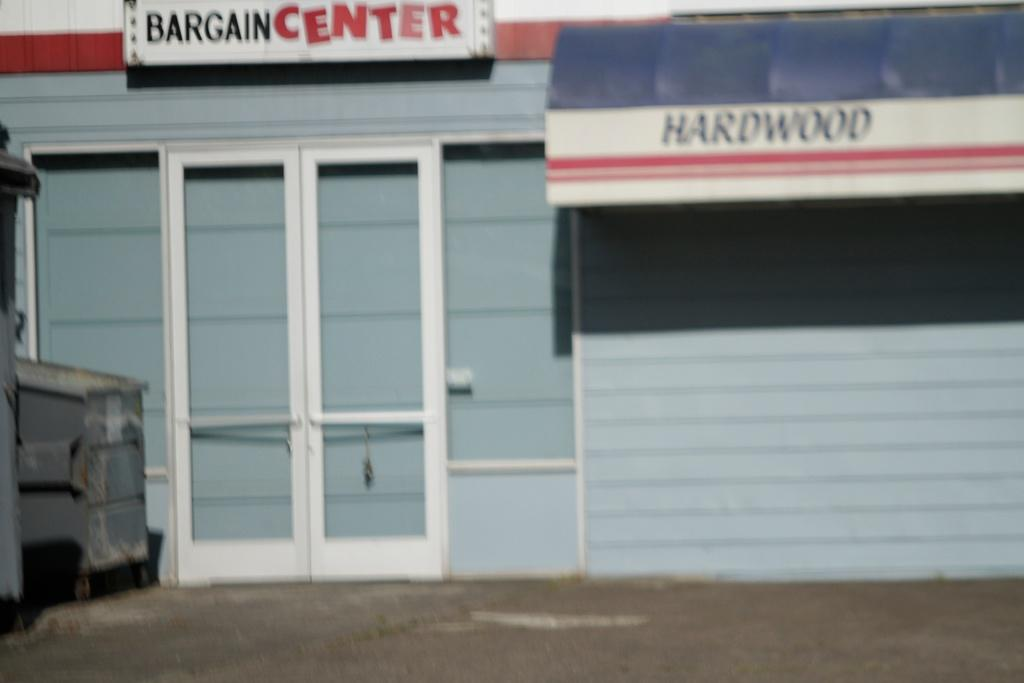What type of structure is visible in the image? There is a building in the image. What is the board used for in the image? The board's purpose is not clear from the image, but it is present. What is attached to the building in the image? There is a banner with text attached to the building. How can someone enter the building in the image? There is a door in the image that can be used to enter the building. What objects are near the door in the image? There are objects near the door, but their specific nature is not clear from the image. What type of cloud can be seen in the image? There is no cloud visible in the image; it features a building, board, banner, door, and nearby objects. What type of vessel is being used by the eye in the image? There is no vessel or eye present in the image. 